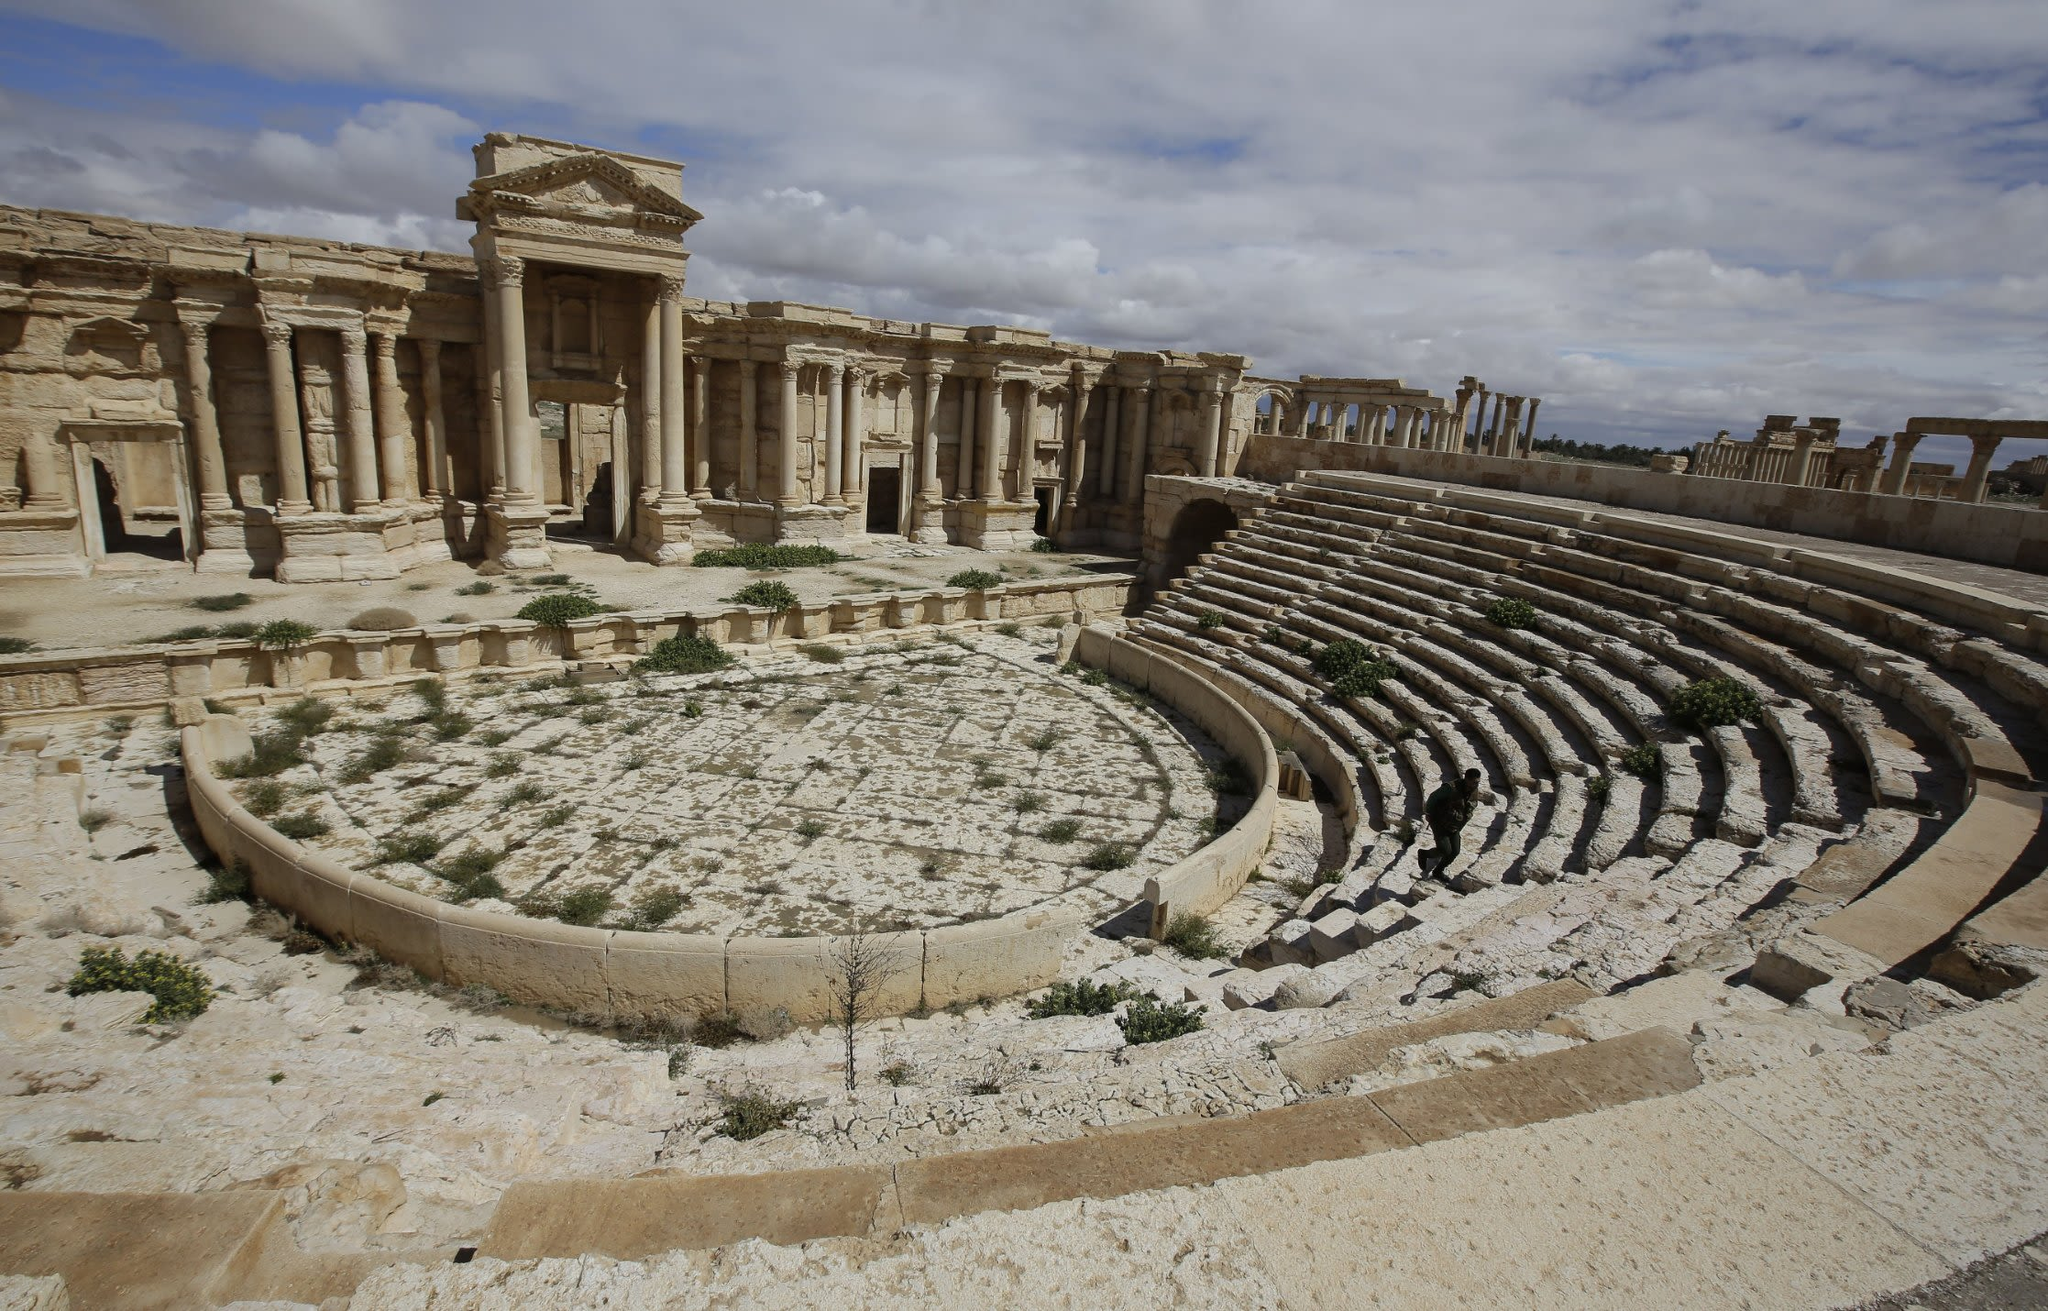Describe the historical significance of this theater. This ancient theater in Palmyra, Syria, is a testament to the city's remarkable history, serving as a cultural and social hub during its prime. Built during the early second century AD, it exemplifies Roman architectural influence with its semi-circular structure and ornate columns. The theater hosted numerous performances, public gatherings, and possibly gladiatorial combats, reflecting the social dynamics and entertainment preferences of that era. The preservation of this site amidst the ravages of time highlights its importance in archaeological studies, offering insights into the technological and artistic advancements of the ancient civilization. How did the architecture of this theater influence modern theater design? The architecture of ancient theaters like this one in Palmyra profoundly influenced modern theater design. The semi-circular arrangement of seating, known as the cavea, ensured optimal acoustics and visibility, principles still used in contemporary theater design. The use of natural landscapes for acoustic enhancement and the integration of elaborate backdrops (scaenae frons) set a precedent for modern stage design. Additionally, the emphasis on audience engagement and sightlines in ancient theaters has guided the ergonomic and aesthetic considerations in the construction of modern performance spaces. 